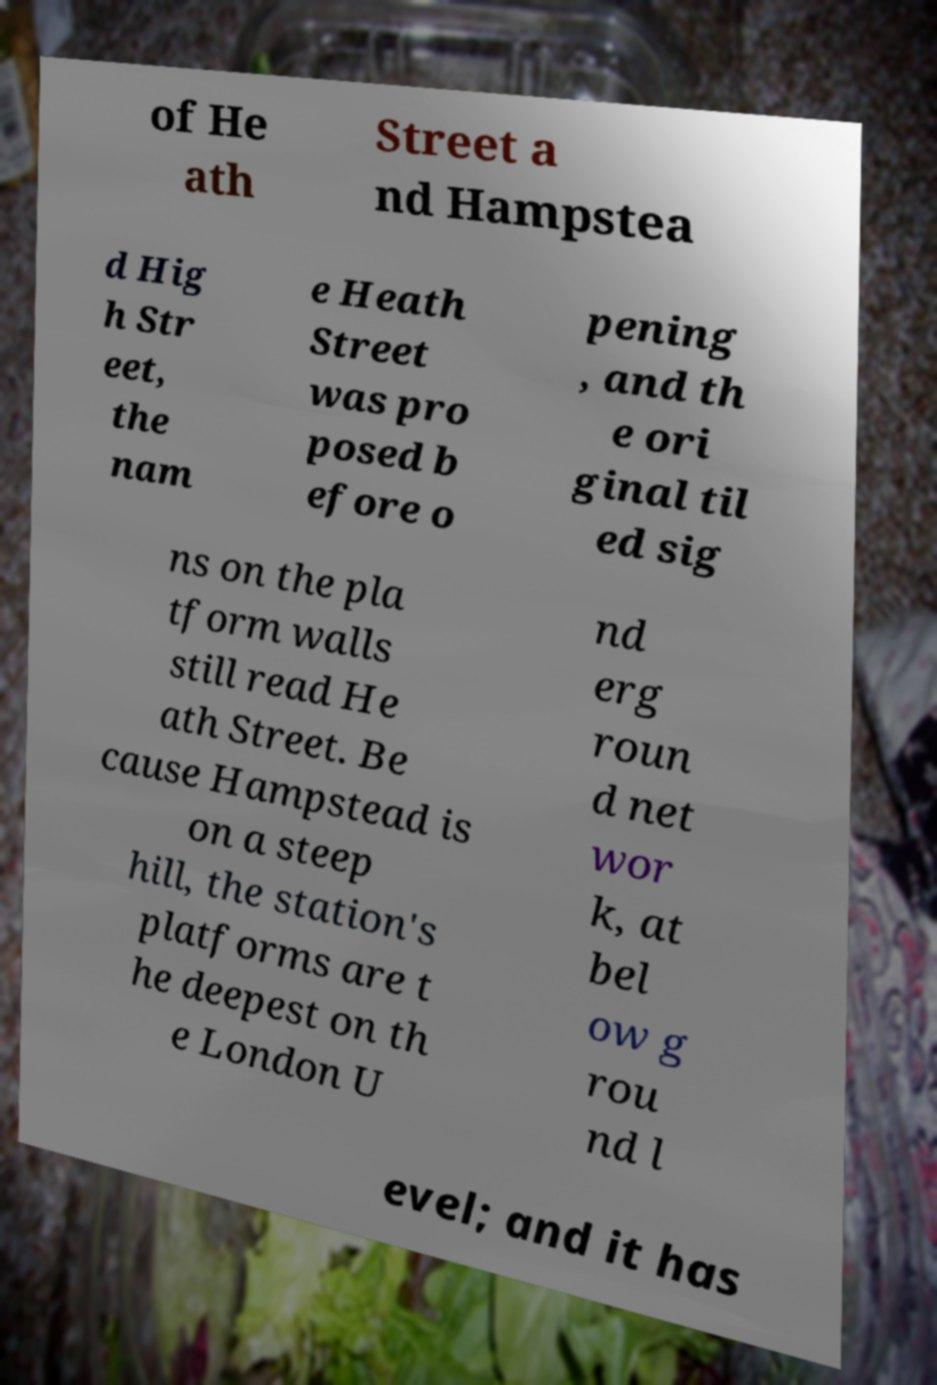Can you read and provide the text displayed in the image?This photo seems to have some interesting text. Can you extract and type it out for me? of He ath Street a nd Hampstea d Hig h Str eet, the nam e Heath Street was pro posed b efore o pening , and th e ori ginal til ed sig ns on the pla tform walls still read He ath Street. Be cause Hampstead is on a steep hill, the station's platforms are t he deepest on th e London U nd erg roun d net wor k, at bel ow g rou nd l evel; and it has 